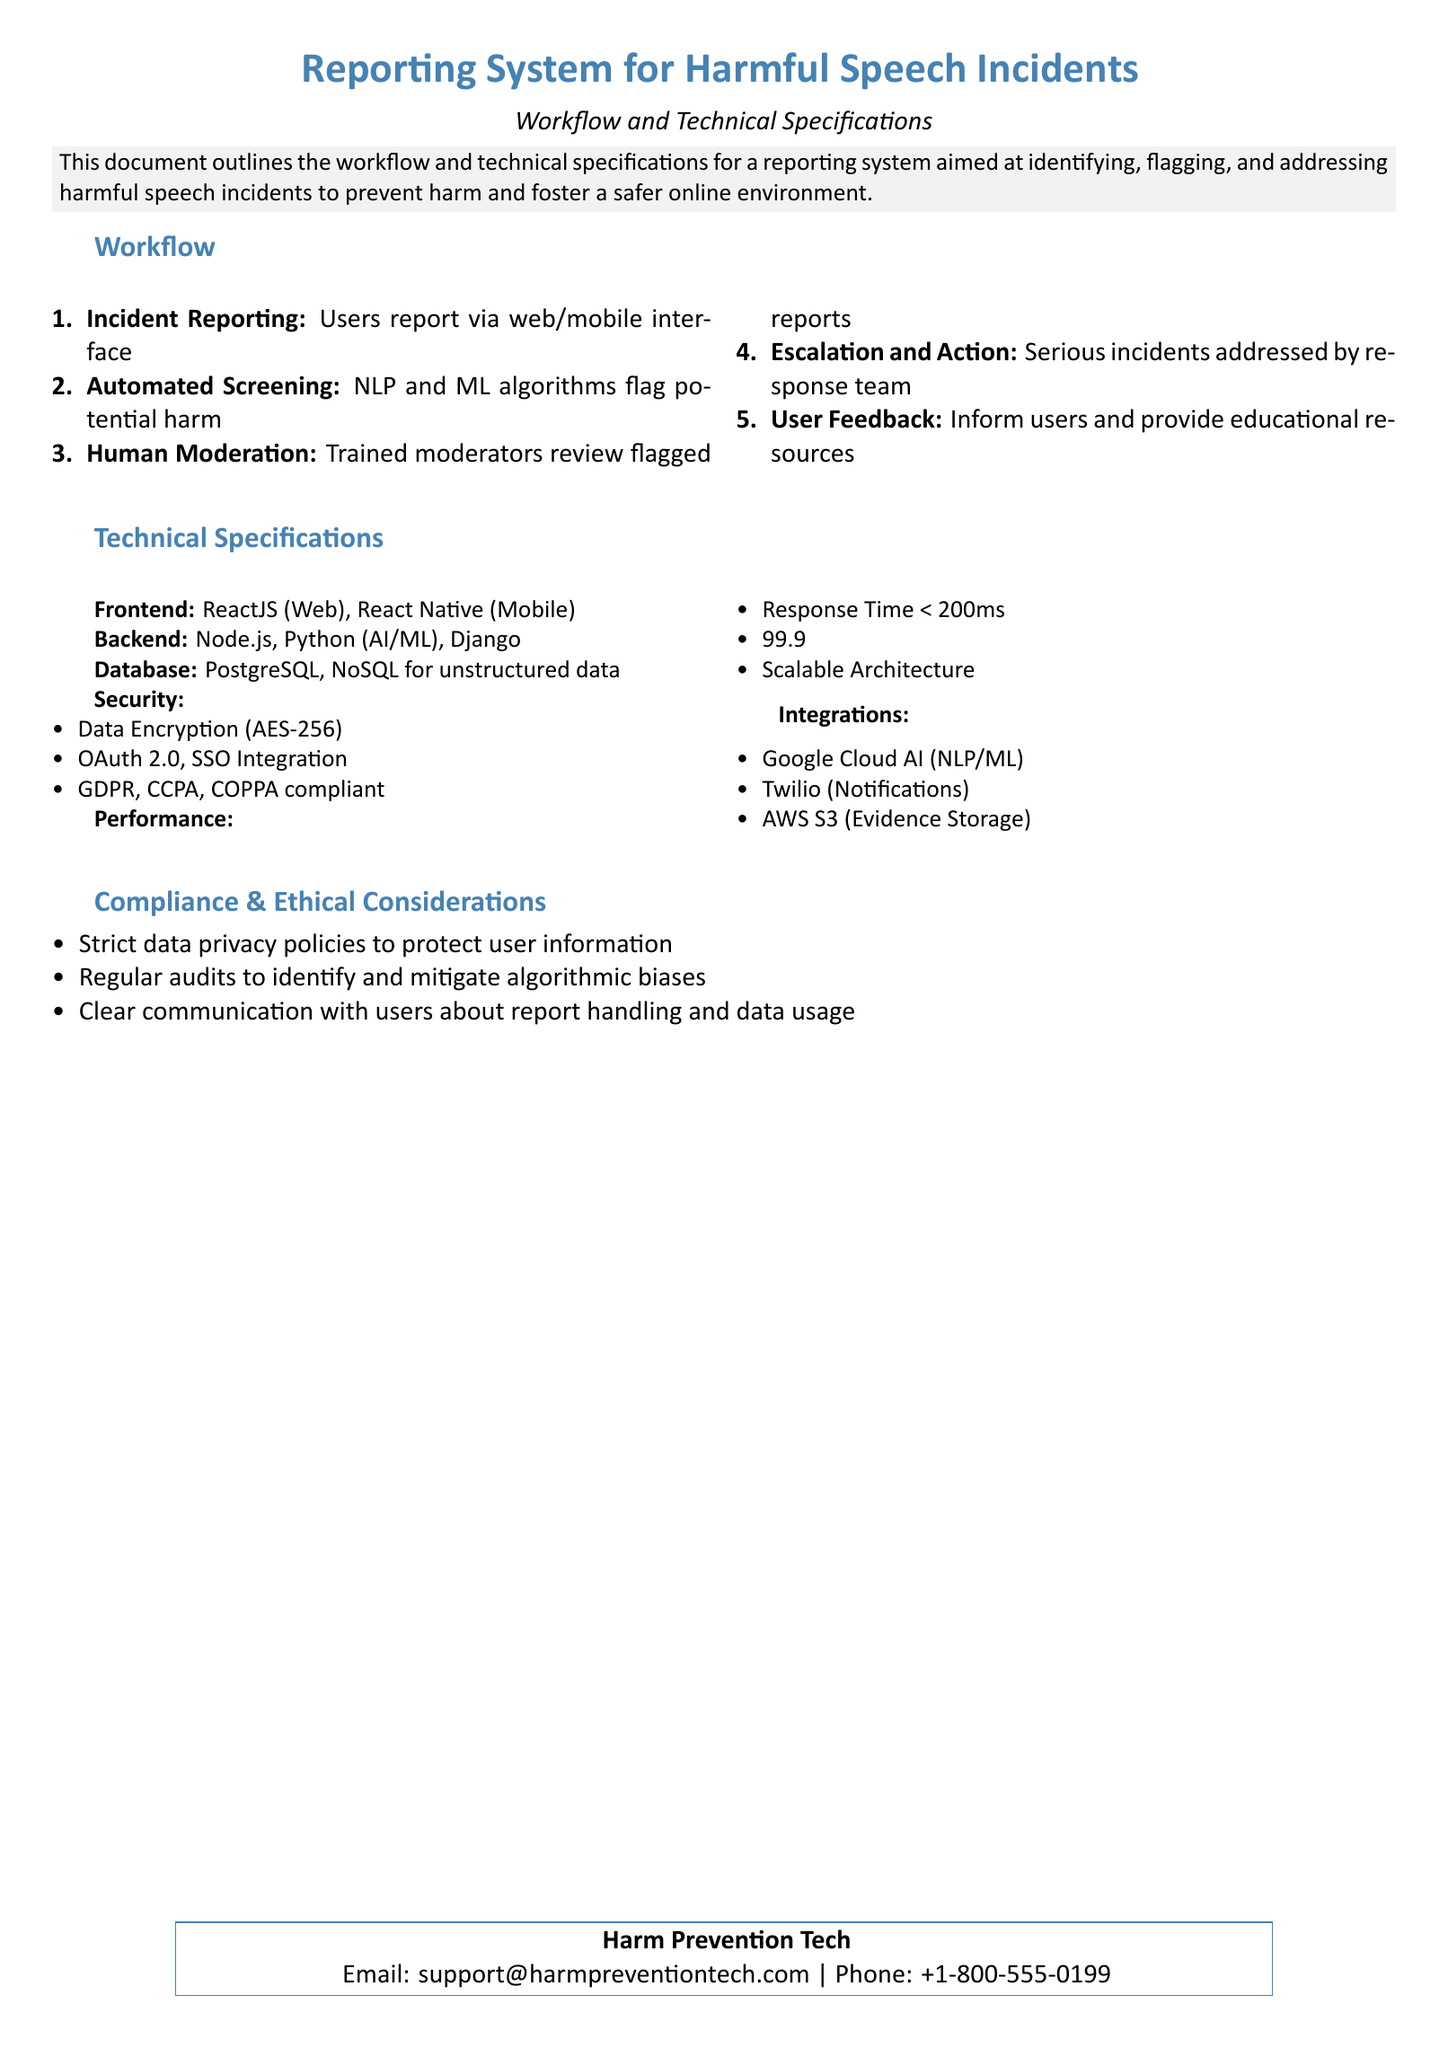what is the main purpose of the document? The main purpose of the document is to outline the workflow and technical specifications for a reporting system aimed at identifying, flagging, and addressing harmful speech incidents to prevent harm and foster a safer online environment.
Answer: prevent harm and foster a safer online environment how many steps are in the incident reporting workflow? By counting the entries in the workflow section, we find there are five steps.
Answer: 5 what technology is used for the frontend development? The document specifies ReactJS for web and React Native for mobile as the frontend technologies used.
Answer: ReactJS, React Native what is the response time requirement for the system? The document states that the system should have a response time of less than 200 milliseconds.
Answer: < 200ms which security measure is mentioned for data encryption? The document lists AES-256 as the data encryption method employed for security.
Answer: AES-256 what language is used for AI/ML in the backend? The backend specification includes Python as the language used for AI/ML.
Answer: Python how does the system ensure compliance with data privacy laws? The document indicates that the system is GDPR, CCPA, and COPPA compliant to ensure data privacy.
Answer: GDPR, CCPA, COPPA compliant what is the uptime requirement stated in the document? The document specifies a uptime requirement of 99.9%.
Answer: 99.9% Uptime 